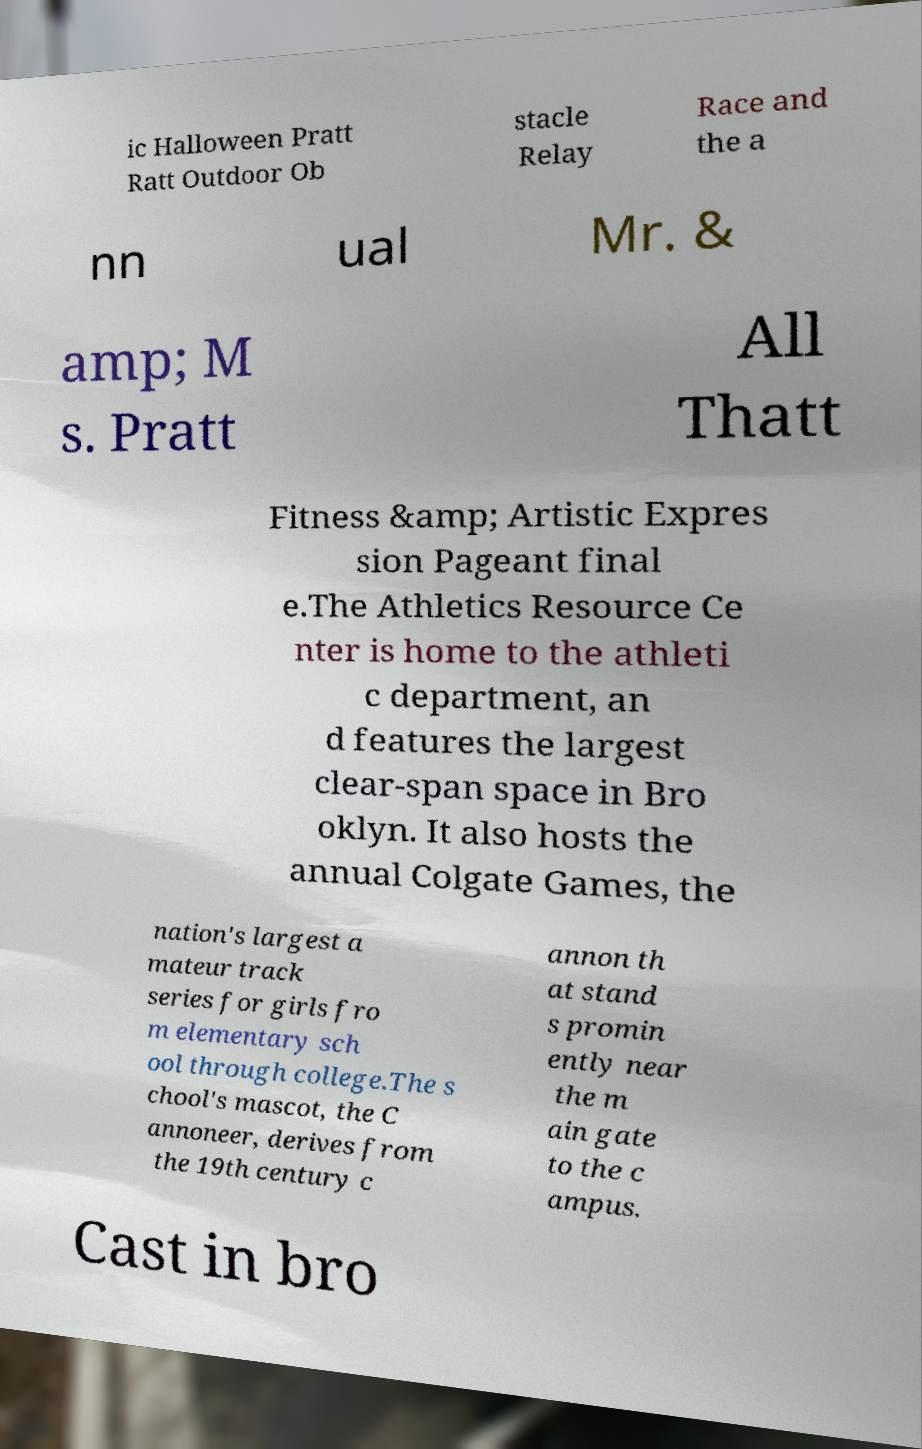Could you assist in decoding the text presented in this image and type it out clearly? ic Halloween Pratt Ratt Outdoor Ob stacle Relay Race and the a nn ual Mr. & amp; M s. Pratt All Thatt Fitness &amp; Artistic Expres sion Pageant final e.The Athletics Resource Ce nter is home to the athleti c department, an d features the largest clear-span space in Bro oklyn. It also hosts the annual Colgate Games, the nation's largest a mateur track series for girls fro m elementary sch ool through college.The s chool's mascot, the C annoneer, derives from the 19th century c annon th at stand s promin ently near the m ain gate to the c ampus. Cast in bro 